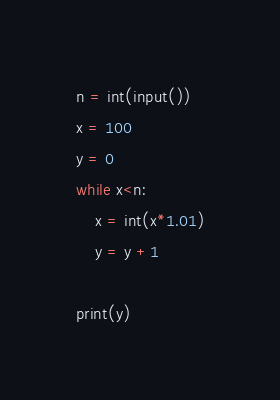<code> <loc_0><loc_0><loc_500><loc_500><_Python_>n = int(input())
x = 100
y = 0
while x<n:
    x = int(x*1.01)
    y = y +1

print(y)</code> 